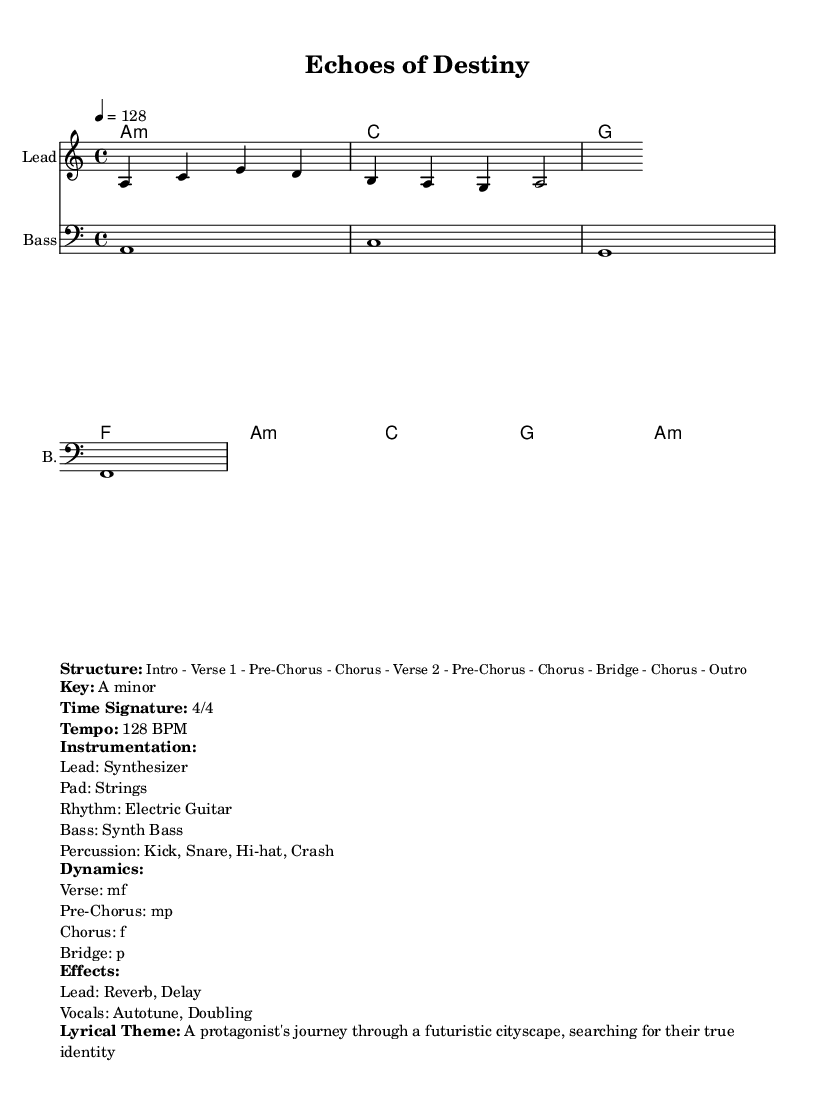What is the key signature of this music? The key signature is A minor, which typically has no sharps or flats. This can be inferred from the global settings within the sheet music.
Answer: A minor What is the time signature of the music? The time signature is indicated as 4/4, which means there are four beats in a measure and a quarter note receives one beat. This is stated in the global settings as well.
Answer: 4/4 What is the tempo of the piece? The tempo is set at 128 BPM, as marked in the global section of the sheet music. This indicates a moderate to fast speed for the performance.
Answer: 128 BPM Which section is marked as the dynamic "mf"? The dynamic "mf" (mezzo-forte), which means moderately loud, applies to the Verse section of the song as mentioned in the dynamics markup.
Answer: Verse What is the main lyrical theme of the music? The lyrical theme is described as "A protagonist's journey through a futuristic cityscape, searching for their true identity" which gives context to the narrative hinted at in the music.
Answer: A protagonist's journey through a futuristic cityscape, searching for their true identity How many distinct sections are identified in the structure? The structure lists several distinct sections: Intro, Verse 1, Pre-Chorus, Chorus, Verse 2, Pre-Chorus, Chorus, Bridge, Chorus, and Outro, totaling ten sections in the piece.
Answer: Ten What instrumentation is featured in this composition? The instrumentation includes a synthesizer for the lead, strings for the pad, electric guitar for the rhythm, synth bass for the bass, and percussion elements like kick, snare, hi-hat, and crash. This is explicitly outlined in the instrumentation markup.
Answer: Synthesizer, Strings, Electric Guitar, Synth Bass, Kick, Snare, Hi-hat, Crash 